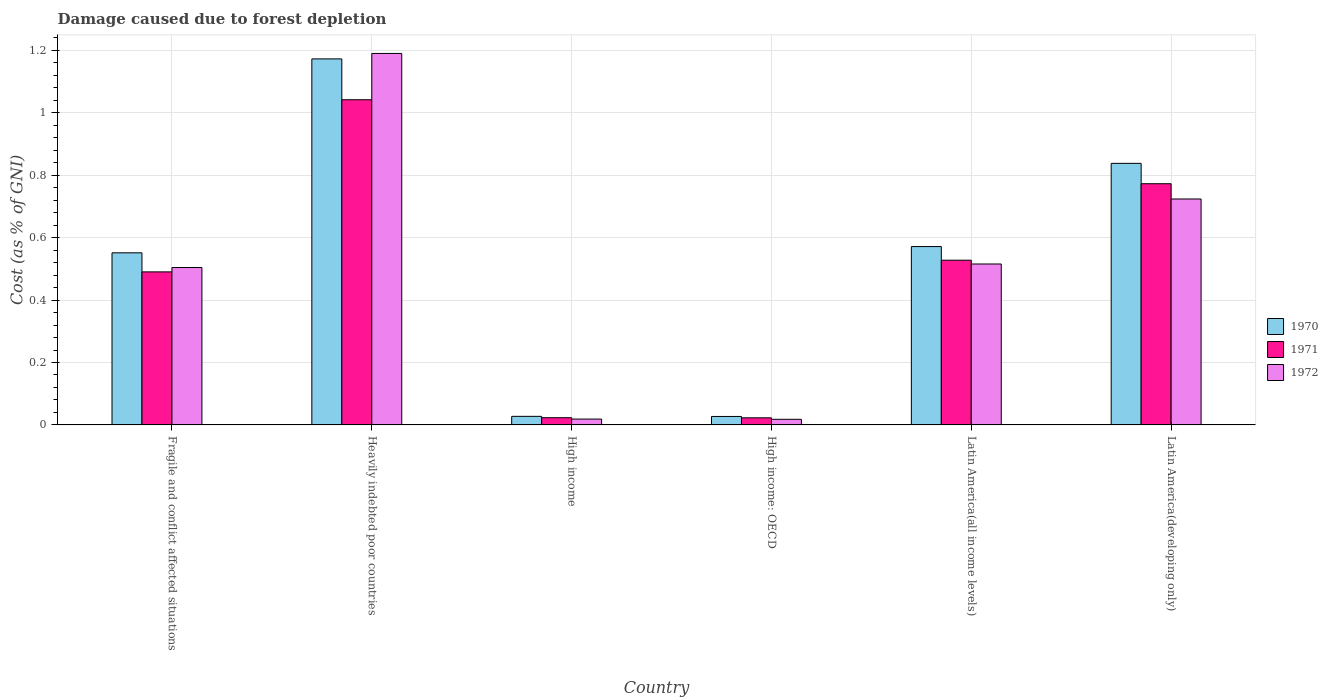What is the label of the 3rd group of bars from the left?
Offer a very short reply. High income. In how many cases, is the number of bars for a given country not equal to the number of legend labels?
Your response must be concise. 0. What is the cost of damage caused due to forest depletion in 1971 in Latin America(all income levels)?
Provide a succinct answer. 0.53. Across all countries, what is the maximum cost of damage caused due to forest depletion in 1972?
Give a very brief answer. 1.19. Across all countries, what is the minimum cost of damage caused due to forest depletion in 1970?
Your response must be concise. 0.03. In which country was the cost of damage caused due to forest depletion in 1970 maximum?
Provide a succinct answer. Heavily indebted poor countries. In which country was the cost of damage caused due to forest depletion in 1971 minimum?
Ensure brevity in your answer.  High income: OECD. What is the total cost of damage caused due to forest depletion in 1971 in the graph?
Provide a succinct answer. 2.88. What is the difference between the cost of damage caused due to forest depletion in 1970 in Fragile and conflict affected situations and that in Latin America(all income levels)?
Offer a very short reply. -0.02. What is the difference between the cost of damage caused due to forest depletion in 1971 in Latin America(developing only) and the cost of damage caused due to forest depletion in 1970 in High income: OECD?
Your answer should be compact. 0.75. What is the average cost of damage caused due to forest depletion in 1972 per country?
Your response must be concise. 0.5. What is the difference between the cost of damage caused due to forest depletion of/in 1970 and cost of damage caused due to forest depletion of/in 1971 in Latin America(developing only)?
Keep it short and to the point. 0.07. In how many countries, is the cost of damage caused due to forest depletion in 1972 greater than 0.7600000000000001 %?
Give a very brief answer. 1. What is the ratio of the cost of damage caused due to forest depletion in 1972 in Heavily indebted poor countries to that in Latin America(developing only)?
Offer a terse response. 1.64. Is the difference between the cost of damage caused due to forest depletion in 1970 in Heavily indebted poor countries and Latin America(developing only) greater than the difference between the cost of damage caused due to forest depletion in 1971 in Heavily indebted poor countries and Latin America(developing only)?
Your response must be concise. Yes. What is the difference between the highest and the second highest cost of damage caused due to forest depletion in 1971?
Your answer should be very brief. -0.27. What is the difference between the highest and the lowest cost of damage caused due to forest depletion in 1971?
Ensure brevity in your answer.  1.02. Is the sum of the cost of damage caused due to forest depletion in 1970 in Fragile and conflict affected situations and Latin America(all income levels) greater than the maximum cost of damage caused due to forest depletion in 1972 across all countries?
Your answer should be very brief. No. What does the 3rd bar from the left in High income represents?
Offer a very short reply. 1972. What does the 1st bar from the right in High income represents?
Provide a short and direct response. 1972. Is it the case that in every country, the sum of the cost of damage caused due to forest depletion in 1971 and cost of damage caused due to forest depletion in 1970 is greater than the cost of damage caused due to forest depletion in 1972?
Ensure brevity in your answer.  Yes. How many bars are there?
Your response must be concise. 18. Where does the legend appear in the graph?
Give a very brief answer. Center right. How many legend labels are there?
Your answer should be very brief. 3. How are the legend labels stacked?
Your response must be concise. Vertical. What is the title of the graph?
Ensure brevity in your answer.  Damage caused due to forest depletion. Does "1970" appear as one of the legend labels in the graph?
Make the answer very short. Yes. What is the label or title of the Y-axis?
Offer a very short reply. Cost (as % of GNI). What is the Cost (as % of GNI) of 1970 in Fragile and conflict affected situations?
Provide a succinct answer. 0.55. What is the Cost (as % of GNI) in 1971 in Fragile and conflict affected situations?
Offer a terse response. 0.49. What is the Cost (as % of GNI) of 1972 in Fragile and conflict affected situations?
Provide a short and direct response. 0.5. What is the Cost (as % of GNI) of 1970 in Heavily indebted poor countries?
Make the answer very short. 1.17. What is the Cost (as % of GNI) in 1971 in Heavily indebted poor countries?
Your answer should be very brief. 1.04. What is the Cost (as % of GNI) of 1972 in Heavily indebted poor countries?
Offer a very short reply. 1.19. What is the Cost (as % of GNI) of 1970 in High income?
Give a very brief answer. 0.03. What is the Cost (as % of GNI) in 1971 in High income?
Keep it short and to the point. 0.02. What is the Cost (as % of GNI) of 1972 in High income?
Offer a very short reply. 0.02. What is the Cost (as % of GNI) of 1970 in High income: OECD?
Offer a terse response. 0.03. What is the Cost (as % of GNI) of 1971 in High income: OECD?
Keep it short and to the point. 0.02. What is the Cost (as % of GNI) in 1972 in High income: OECD?
Your response must be concise. 0.02. What is the Cost (as % of GNI) in 1970 in Latin America(all income levels)?
Provide a succinct answer. 0.57. What is the Cost (as % of GNI) in 1971 in Latin America(all income levels)?
Offer a very short reply. 0.53. What is the Cost (as % of GNI) of 1972 in Latin America(all income levels)?
Make the answer very short. 0.52. What is the Cost (as % of GNI) in 1970 in Latin America(developing only)?
Offer a terse response. 0.84. What is the Cost (as % of GNI) of 1971 in Latin America(developing only)?
Offer a very short reply. 0.77. What is the Cost (as % of GNI) of 1972 in Latin America(developing only)?
Make the answer very short. 0.72. Across all countries, what is the maximum Cost (as % of GNI) in 1970?
Offer a very short reply. 1.17. Across all countries, what is the maximum Cost (as % of GNI) of 1971?
Your response must be concise. 1.04. Across all countries, what is the maximum Cost (as % of GNI) of 1972?
Your answer should be very brief. 1.19. Across all countries, what is the minimum Cost (as % of GNI) in 1970?
Give a very brief answer. 0.03. Across all countries, what is the minimum Cost (as % of GNI) in 1971?
Your response must be concise. 0.02. Across all countries, what is the minimum Cost (as % of GNI) of 1972?
Keep it short and to the point. 0.02. What is the total Cost (as % of GNI) of 1970 in the graph?
Make the answer very short. 3.19. What is the total Cost (as % of GNI) in 1971 in the graph?
Your response must be concise. 2.88. What is the total Cost (as % of GNI) in 1972 in the graph?
Your answer should be compact. 2.97. What is the difference between the Cost (as % of GNI) in 1970 in Fragile and conflict affected situations and that in Heavily indebted poor countries?
Keep it short and to the point. -0.62. What is the difference between the Cost (as % of GNI) in 1971 in Fragile and conflict affected situations and that in Heavily indebted poor countries?
Offer a very short reply. -0.55. What is the difference between the Cost (as % of GNI) of 1972 in Fragile and conflict affected situations and that in Heavily indebted poor countries?
Offer a very short reply. -0.69. What is the difference between the Cost (as % of GNI) of 1970 in Fragile and conflict affected situations and that in High income?
Offer a very short reply. 0.52. What is the difference between the Cost (as % of GNI) of 1971 in Fragile and conflict affected situations and that in High income?
Your answer should be compact. 0.47. What is the difference between the Cost (as % of GNI) of 1972 in Fragile and conflict affected situations and that in High income?
Offer a terse response. 0.49. What is the difference between the Cost (as % of GNI) in 1970 in Fragile and conflict affected situations and that in High income: OECD?
Your answer should be very brief. 0.52. What is the difference between the Cost (as % of GNI) of 1971 in Fragile and conflict affected situations and that in High income: OECD?
Your answer should be compact. 0.47. What is the difference between the Cost (as % of GNI) in 1972 in Fragile and conflict affected situations and that in High income: OECD?
Your answer should be compact. 0.49. What is the difference between the Cost (as % of GNI) of 1970 in Fragile and conflict affected situations and that in Latin America(all income levels)?
Your answer should be very brief. -0.02. What is the difference between the Cost (as % of GNI) of 1971 in Fragile and conflict affected situations and that in Latin America(all income levels)?
Offer a terse response. -0.04. What is the difference between the Cost (as % of GNI) in 1972 in Fragile and conflict affected situations and that in Latin America(all income levels)?
Your response must be concise. -0.01. What is the difference between the Cost (as % of GNI) of 1970 in Fragile and conflict affected situations and that in Latin America(developing only)?
Ensure brevity in your answer.  -0.29. What is the difference between the Cost (as % of GNI) in 1971 in Fragile and conflict affected situations and that in Latin America(developing only)?
Your answer should be compact. -0.28. What is the difference between the Cost (as % of GNI) of 1972 in Fragile and conflict affected situations and that in Latin America(developing only)?
Give a very brief answer. -0.22. What is the difference between the Cost (as % of GNI) of 1970 in Heavily indebted poor countries and that in High income?
Your response must be concise. 1.15. What is the difference between the Cost (as % of GNI) in 1971 in Heavily indebted poor countries and that in High income?
Provide a succinct answer. 1.02. What is the difference between the Cost (as % of GNI) in 1972 in Heavily indebted poor countries and that in High income?
Keep it short and to the point. 1.17. What is the difference between the Cost (as % of GNI) of 1970 in Heavily indebted poor countries and that in High income: OECD?
Ensure brevity in your answer.  1.15. What is the difference between the Cost (as % of GNI) of 1971 in Heavily indebted poor countries and that in High income: OECD?
Your answer should be compact. 1.02. What is the difference between the Cost (as % of GNI) of 1972 in Heavily indebted poor countries and that in High income: OECD?
Your answer should be very brief. 1.17. What is the difference between the Cost (as % of GNI) in 1970 in Heavily indebted poor countries and that in Latin America(all income levels)?
Make the answer very short. 0.6. What is the difference between the Cost (as % of GNI) of 1971 in Heavily indebted poor countries and that in Latin America(all income levels)?
Ensure brevity in your answer.  0.51. What is the difference between the Cost (as % of GNI) in 1972 in Heavily indebted poor countries and that in Latin America(all income levels)?
Give a very brief answer. 0.67. What is the difference between the Cost (as % of GNI) of 1970 in Heavily indebted poor countries and that in Latin America(developing only)?
Provide a succinct answer. 0.33. What is the difference between the Cost (as % of GNI) of 1971 in Heavily indebted poor countries and that in Latin America(developing only)?
Offer a terse response. 0.27. What is the difference between the Cost (as % of GNI) in 1972 in Heavily indebted poor countries and that in Latin America(developing only)?
Offer a terse response. 0.47. What is the difference between the Cost (as % of GNI) in 1970 in High income and that in High income: OECD?
Offer a very short reply. 0. What is the difference between the Cost (as % of GNI) of 1971 in High income and that in High income: OECD?
Give a very brief answer. 0. What is the difference between the Cost (as % of GNI) in 1972 in High income and that in High income: OECD?
Offer a very short reply. 0. What is the difference between the Cost (as % of GNI) of 1970 in High income and that in Latin America(all income levels)?
Your response must be concise. -0.54. What is the difference between the Cost (as % of GNI) of 1971 in High income and that in Latin America(all income levels)?
Offer a very short reply. -0.5. What is the difference between the Cost (as % of GNI) of 1972 in High income and that in Latin America(all income levels)?
Offer a terse response. -0.5. What is the difference between the Cost (as % of GNI) of 1970 in High income and that in Latin America(developing only)?
Your answer should be very brief. -0.81. What is the difference between the Cost (as % of GNI) of 1971 in High income and that in Latin America(developing only)?
Offer a very short reply. -0.75. What is the difference between the Cost (as % of GNI) of 1972 in High income and that in Latin America(developing only)?
Offer a very short reply. -0.71. What is the difference between the Cost (as % of GNI) in 1970 in High income: OECD and that in Latin America(all income levels)?
Offer a very short reply. -0.54. What is the difference between the Cost (as % of GNI) of 1971 in High income: OECD and that in Latin America(all income levels)?
Your answer should be compact. -0.51. What is the difference between the Cost (as % of GNI) in 1972 in High income: OECD and that in Latin America(all income levels)?
Keep it short and to the point. -0.5. What is the difference between the Cost (as % of GNI) of 1970 in High income: OECD and that in Latin America(developing only)?
Ensure brevity in your answer.  -0.81. What is the difference between the Cost (as % of GNI) in 1971 in High income: OECD and that in Latin America(developing only)?
Your response must be concise. -0.75. What is the difference between the Cost (as % of GNI) in 1972 in High income: OECD and that in Latin America(developing only)?
Offer a terse response. -0.71. What is the difference between the Cost (as % of GNI) of 1970 in Latin America(all income levels) and that in Latin America(developing only)?
Provide a short and direct response. -0.27. What is the difference between the Cost (as % of GNI) in 1971 in Latin America(all income levels) and that in Latin America(developing only)?
Your answer should be very brief. -0.25. What is the difference between the Cost (as % of GNI) of 1972 in Latin America(all income levels) and that in Latin America(developing only)?
Ensure brevity in your answer.  -0.21. What is the difference between the Cost (as % of GNI) of 1970 in Fragile and conflict affected situations and the Cost (as % of GNI) of 1971 in Heavily indebted poor countries?
Make the answer very short. -0.49. What is the difference between the Cost (as % of GNI) of 1970 in Fragile and conflict affected situations and the Cost (as % of GNI) of 1972 in Heavily indebted poor countries?
Offer a very short reply. -0.64. What is the difference between the Cost (as % of GNI) in 1970 in Fragile and conflict affected situations and the Cost (as % of GNI) in 1971 in High income?
Give a very brief answer. 0.53. What is the difference between the Cost (as % of GNI) of 1970 in Fragile and conflict affected situations and the Cost (as % of GNI) of 1972 in High income?
Your response must be concise. 0.53. What is the difference between the Cost (as % of GNI) in 1971 in Fragile and conflict affected situations and the Cost (as % of GNI) in 1972 in High income?
Give a very brief answer. 0.47. What is the difference between the Cost (as % of GNI) in 1970 in Fragile and conflict affected situations and the Cost (as % of GNI) in 1971 in High income: OECD?
Make the answer very short. 0.53. What is the difference between the Cost (as % of GNI) in 1970 in Fragile and conflict affected situations and the Cost (as % of GNI) in 1972 in High income: OECD?
Keep it short and to the point. 0.53. What is the difference between the Cost (as % of GNI) of 1971 in Fragile and conflict affected situations and the Cost (as % of GNI) of 1972 in High income: OECD?
Make the answer very short. 0.47. What is the difference between the Cost (as % of GNI) in 1970 in Fragile and conflict affected situations and the Cost (as % of GNI) in 1971 in Latin America(all income levels)?
Your answer should be very brief. 0.02. What is the difference between the Cost (as % of GNI) in 1970 in Fragile and conflict affected situations and the Cost (as % of GNI) in 1972 in Latin America(all income levels)?
Ensure brevity in your answer.  0.04. What is the difference between the Cost (as % of GNI) in 1971 in Fragile and conflict affected situations and the Cost (as % of GNI) in 1972 in Latin America(all income levels)?
Your answer should be very brief. -0.03. What is the difference between the Cost (as % of GNI) in 1970 in Fragile and conflict affected situations and the Cost (as % of GNI) in 1971 in Latin America(developing only)?
Your answer should be very brief. -0.22. What is the difference between the Cost (as % of GNI) of 1970 in Fragile and conflict affected situations and the Cost (as % of GNI) of 1972 in Latin America(developing only)?
Ensure brevity in your answer.  -0.17. What is the difference between the Cost (as % of GNI) in 1971 in Fragile and conflict affected situations and the Cost (as % of GNI) in 1972 in Latin America(developing only)?
Ensure brevity in your answer.  -0.23. What is the difference between the Cost (as % of GNI) of 1970 in Heavily indebted poor countries and the Cost (as % of GNI) of 1971 in High income?
Ensure brevity in your answer.  1.15. What is the difference between the Cost (as % of GNI) in 1970 in Heavily indebted poor countries and the Cost (as % of GNI) in 1972 in High income?
Offer a terse response. 1.15. What is the difference between the Cost (as % of GNI) of 1971 in Heavily indebted poor countries and the Cost (as % of GNI) of 1972 in High income?
Make the answer very short. 1.02. What is the difference between the Cost (as % of GNI) in 1970 in Heavily indebted poor countries and the Cost (as % of GNI) in 1971 in High income: OECD?
Offer a terse response. 1.15. What is the difference between the Cost (as % of GNI) of 1970 in Heavily indebted poor countries and the Cost (as % of GNI) of 1972 in High income: OECD?
Provide a succinct answer. 1.15. What is the difference between the Cost (as % of GNI) of 1971 in Heavily indebted poor countries and the Cost (as % of GNI) of 1972 in High income: OECD?
Offer a very short reply. 1.02. What is the difference between the Cost (as % of GNI) of 1970 in Heavily indebted poor countries and the Cost (as % of GNI) of 1971 in Latin America(all income levels)?
Offer a very short reply. 0.65. What is the difference between the Cost (as % of GNI) of 1970 in Heavily indebted poor countries and the Cost (as % of GNI) of 1972 in Latin America(all income levels)?
Provide a succinct answer. 0.66. What is the difference between the Cost (as % of GNI) of 1971 in Heavily indebted poor countries and the Cost (as % of GNI) of 1972 in Latin America(all income levels)?
Provide a short and direct response. 0.53. What is the difference between the Cost (as % of GNI) of 1970 in Heavily indebted poor countries and the Cost (as % of GNI) of 1972 in Latin America(developing only)?
Give a very brief answer. 0.45. What is the difference between the Cost (as % of GNI) of 1971 in Heavily indebted poor countries and the Cost (as % of GNI) of 1972 in Latin America(developing only)?
Provide a succinct answer. 0.32. What is the difference between the Cost (as % of GNI) of 1970 in High income and the Cost (as % of GNI) of 1971 in High income: OECD?
Give a very brief answer. 0. What is the difference between the Cost (as % of GNI) in 1970 in High income and the Cost (as % of GNI) in 1972 in High income: OECD?
Make the answer very short. 0.01. What is the difference between the Cost (as % of GNI) of 1971 in High income and the Cost (as % of GNI) of 1972 in High income: OECD?
Your answer should be compact. 0.01. What is the difference between the Cost (as % of GNI) in 1970 in High income and the Cost (as % of GNI) in 1971 in Latin America(all income levels)?
Provide a succinct answer. -0.5. What is the difference between the Cost (as % of GNI) of 1970 in High income and the Cost (as % of GNI) of 1972 in Latin America(all income levels)?
Offer a terse response. -0.49. What is the difference between the Cost (as % of GNI) in 1971 in High income and the Cost (as % of GNI) in 1972 in Latin America(all income levels)?
Ensure brevity in your answer.  -0.49. What is the difference between the Cost (as % of GNI) in 1970 in High income and the Cost (as % of GNI) in 1971 in Latin America(developing only)?
Provide a succinct answer. -0.75. What is the difference between the Cost (as % of GNI) of 1970 in High income and the Cost (as % of GNI) of 1972 in Latin America(developing only)?
Your response must be concise. -0.7. What is the difference between the Cost (as % of GNI) of 1971 in High income and the Cost (as % of GNI) of 1972 in Latin America(developing only)?
Your answer should be compact. -0.7. What is the difference between the Cost (as % of GNI) in 1970 in High income: OECD and the Cost (as % of GNI) in 1971 in Latin America(all income levels)?
Provide a succinct answer. -0.5. What is the difference between the Cost (as % of GNI) in 1970 in High income: OECD and the Cost (as % of GNI) in 1972 in Latin America(all income levels)?
Offer a very short reply. -0.49. What is the difference between the Cost (as % of GNI) in 1971 in High income: OECD and the Cost (as % of GNI) in 1972 in Latin America(all income levels)?
Offer a terse response. -0.49. What is the difference between the Cost (as % of GNI) of 1970 in High income: OECD and the Cost (as % of GNI) of 1971 in Latin America(developing only)?
Your answer should be very brief. -0.75. What is the difference between the Cost (as % of GNI) of 1970 in High income: OECD and the Cost (as % of GNI) of 1972 in Latin America(developing only)?
Your response must be concise. -0.7. What is the difference between the Cost (as % of GNI) in 1971 in High income: OECD and the Cost (as % of GNI) in 1972 in Latin America(developing only)?
Give a very brief answer. -0.7. What is the difference between the Cost (as % of GNI) of 1970 in Latin America(all income levels) and the Cost (as % of GNI) of 1971 in Latin America(developing only)?
Your answer should be compact. -0.2. What is the difference between the Cost (as % of GNI) of 1970 in Latin America(all income levels) and the Cost (as % of GNI) of 1972 in Latin America(developing only)?
Keep it short and to the point. -0.15. What is the difference between the Cost (as % of GNI) of 1971 in Latin America(all income levels) and the Cost (as % of GNI) of 1972 in Latin America(developing only)?
Make the answer very short. -0.2. What is the average Cost (as % of GNI) of 1970 per country?
Make the answer very short. 0.53. What is the average Cost (as % of GNI) in 1971 per country?
Your answer should be compact. 0.48. What is the average Cost (as % of GNI) in 1972 per country?
Your answer should be very brief. 0.5. What is the difference between the Cost (as % of GNI) in 1970 and Cost (as % of GNI) in 1971 in Fragile and conflict affected situations?
Provide a short and direct response. 0.06. What is the difference between the Cost (as % of GNI) of 1970 and Cost (as % of GNI) of 1972 in Fragile and conflict affected situations?
Provide a short and direct response. 0.05. What is the difference between the Cost (as % of GNI) in 1971 and Cost (as % of GNI) in 1972 in Fragile and conflict affected situations?
Provide a succinct answer. -0.01. What is the difference between the Cost (as % of GNI) in 1970 and Cost (as % of GNI) in 1971 in Heavily indebted poor countries?
Your answer should be compact. 0.13. What is the difference between the Cost (as % of GNI) of 1970 and Cost (as % of GNI) of 1972 in Heavily indebted poor countries?
Provide a succinct answer. -0.02. What is the difference between the Cost (as % of GNI) in 1971 and Cost (as % of GNI) in 1972 in Heavily indebted poor countries?
Give a very brief answer. -0.15. What is the difference between the Cost (as % of GNI) in 1970 and Cost (as % of GNI) in 1971 in High income?
Ensure brevity in your answer.  0. What is the difference between the Cost (as % of GNI) of 1970 and Cost (as % of GNI) of 1972 in High income?
Provide a short and direct response. 0.01. What is the difference between the Cost (as % of GNI) of 1971 and Cost (as % of GNI) of 1972 in High income?
Your answer should be compact. 0. What is the difference between the Cost (as % of GNI) in 1970 and Cost (as % of GNI) in 1971 in High income: OECD?
Your answer should be very brief. 0. What is the difference between the Cost (as % of GNI) of 1970 and Cost (as % of GNI) of 1972 in High income: OECD?
Provide a short and direct response. 0.01. What is the difference between the Cost (as % of GNI) in 1971 and Cost (as % of GNI) in 1972 in High income: OECD?
Offer a very short reply. 0. What is the difference between the Cost (as % of GNI) in 1970 and Cost (as % of GNI) in 1971 in Latin America(all income levels)?
Give a very brief answer. 0.04. What is the difference between the Cost (as % of GNI) of 1970 and Cost (as % of GNI) of 1972 in Latin America(all income levels)?
Your answer should be very brief. 0.06. What is the difference between the Cost (as % of GNI) of 1971 and Cost (as % of GNI) of 1972 in Latin America(all income levels)?
Make the answer very short. 0.01. What is the difference between the Cost (as % of GNI) in 1970 and Cost (as % of GNI) in 1971 in Latin America(developing only)?
Your answer should be compact. 0.07. What is the difference between the Cost (as % of GNI) in 1970 and Cost (as % of GNI) in 1972 in Latin America(developing only)?
Your answer should be compact. 0.11. What is the difference between the Cost (as % of GNI) in 1971 and Cost (as % of GNI) in 1972 in Latin America(developing only)?
Your response must be concise. 0.05. What is the ratio of the Cost (as % of GNI) of 1970 in Fragile and conflict affected situations to that in Heavily indebted poor countries?
Give a very brief answer. 0.47. What is the ratio of the Cost (as % of GNI) in 1971 in Fragile and conflict affected situations to that in Heavily indebted poor countries?
Keep it short and to the point. 0.47. What is the ratio of the Cost (as % of GNI) in 1972 in Fragile and conflict affected situations to that in Heavily indebted poor countries?
Offer a terse response. 0.42. What is the ratio of the Cost (as % of GNI) in 1970 in Fragile and conflict affected situations to that in High income?
Provide a succinct answer. 20.11. What is the ratio of the Cost (as % of GNI) of 1971 in Fragile and conflict affected situations to that in High income?
Give a very brief answer. 21.22. What is the ratio of the Cost (as % of GNI) of 1972 in Fragile and conflict affected situations to that in High income?
Offer a terse response. 26.95. What is the ratio of the Cost (as % of GNI) in 1970 in Fragile and conflict affected situations to that in High income: OECD?
Your answer should be very brief. 20.35. What is the ratio of the Cost (as % of GNI) of 1971 in Fragile and conflict affected situations to that in High income: OECD?
Offer a very short reply. 21.58. What is the ratio of the Cost (as % of GNI) of 1972 in Fragile and conflict affected situations to that in High income: OECD?
Give a very brief answer. 28.05. What is the ratio of the Cost (as % of GNI) in 1970 in Fragile and conflict affected situations to that in Latin America(all income levels)?
Your response must be concise. 0.96. What is the ratio of the Cost (as % of GNI) of 1971 in Fragile and conflict affected situations to that in Latin America(all income levels)?
Provide a short and direct response. 0.93. What is the ratio of the Cost (as % of GNI) in 1972 in Fragile and conflict affected situations to that in Latin America(all income levels)?
Your answer should be very brief. 0.98. What is the ratio of the Cost (as % of GNI) in 1970 in Fragile and conflict affected situations to that in Latin America(developing only)?
Your answer should be compact. 0.66. What is the ratio of the Cost (as % of GNI) of 1971 in Fragile and conflict affected situations to that in Latin America(developing only)?
Your answer should be very brief. 0.63. What is the ratio of the Cost (as % of GNI) in 1972 in Fragile and conflict affected situations to that in Latin America(developing only)?
Offer a terse response. 0.7. What is the ratio of the Cost (as % of GNI) of 1970 in Heavily indebted poor countries to that in High income?
Offer a terse response. 42.78. What is the ratio of the Cost (as % of GNI) in 1971 in Heavily indebted poor countries to that in High income?
Give a very brief answer. 45.1. What is the ratio of the Cost (as % of GNI) of 1972 in Heavily indebted poor countries to that in High income?
Provide a short and direct response. 63.61. What is the ratio of the Cost (as % of GNI) in 1970 in Heavily indebted poor countries to that in High income: OECD?
Your answer should be very brief. 43.29. What is the ratio of the Cost (as % of GNI) in 1971 in Heavily indebted poor countries to that in High income: OECD?
Your answer should be compact. 45.86. What is the ratio of the Cost (as % of GNI) of 1972 in Heavily indebted poor countries to that in High income: OECD?
Make the answer very short. 66.22. What is the ratio of the Cost (as % of GNI) of 1970 in Heavily indebted poor countries to that in Latin America(all income levels)?
Keep it short and to the point. 2.05. What is the ratio of the Cost (as % of GNI) in 1971 in Heavily indebted poor countries to that in Latin America(all income levels)?
Keep it short and to the point. 1.97. What is the ratio of the Cost (as % of GNI) of 1972 in Heavily indebted poor countries to that in Latin America(all income levels)?
Your response must be concise. 2.31. What is the ratio of the Cost (as % of GNI) in 1970 in Heavily indebted poor countries to that in Latin America(developing only)?
Provide a short and direct response. 1.4. What is the ratio of the Cost (as % of GNI) of 1971 in Heavily indebted poor countries to that in Latin America(developing only)?
Keep it short and to the point. 1.35. What is the ratio of the Cost (as % of GNI) in 1972 in Heavily indebted poor countries to that in Latin America(developing only)?
Your response must be concise. 1.64. What is the ratio of the Cost (as % of GNI) of 1971 in High income to that in High income: OECD?
Provide a short and direct response. 1.02. What is the ratio of the Cost (as % of GNI) of 1972 in High income to that in High income: OECD?
Keep it short and to the point. 1.04. What is the ratio of the Cost (as % of GNI) of 1970 in High income to that in Latin America(all income levels)?
Your answer should be very brief. 0.05. What is the ratio of the Cost (as % of GNI) of 1971 in High income to that in Latin America(all income levels)?
Keep it short and to the point. 0.04. What is the ratio of the Cost (as % of GNI) in 1972 in High income to that in Latin America(all income levels)?
Keep it short and to the point. 0.04. What is the ratio of the Cost (as % of GNI) of 1970 in High income to that in Latin America(developing only)?
Your response must be concise. 0.03. What is the ratio of the Cost (as % of GNI) of 1971 in High income to that in Latin America(developing only)?
Ensure brevity in your answer.  0.03. What is the ratio of the Cost (as % of GNI) in 1972 in High income to that in Latin America(developing only)?
Your response must be concise. 0.03. What is the ratio of the Cost (as % of GNI) in 1970 in High income: OECD to that in Latin America(all income levels)?
Give a very brief answer. 0.05. What is the ratio of the Cost (as % of GNI) of 1971 in High income: OECD to that in Latin America(all income levels)?
Your answer should be very brief. 0.04. What is the ratio of the Cost (as % of GNI) of 1972 in High income: OECD to that in Latin America(all income levels)?
Your response must be concise. 0.03. What is the ratio of the Cost (as % of GNI) in 1970 in High income: OECD to that in Latin America(developing only)?
Ensure brevity in your answer.  0.03. What is the ratio of the Cost (as % of GNI) of 1971 in High income: OECD to that in Latin America(developing only)?
Give a very brief answer. 0.03. What is the ratio of the Cost (as % of GNI) of 1972 in High income: OECD to that in Latin America(developing only)?
Offer a terse response. 0.02. What is the ratio of the Cost (as % of GNI) of 1970 in Latin America(all income levels) to that in Latin America(developing only)?
Keep it short and to the point. 0.68. What is the ratio of the Cost (as % of GNI) in 1971 in Latin America(all income levels) to that in Latin America(developing only)?
Your answer should be compact. 0.68. What is the ratio of the Cost (as % of GNI) of 1972 in Latin America(all income levels) to that in Latin America(developing only)?
Your answer should be compact. 0.71. What is the difference between the highest and the second highest Cost (as % of GNI) in 1970?
Ensure brevity in your answer.  0.33. What is the difference between the highest and the second highest Cost (as % of GNI) of 1971?
Make the answer very short. 0.27. What is the difference between the highest and the second highest Cost (as % of GNI) of 1972?
Offer a terse response. 0.47. What is the difference between the highest and the lowest Cost (as % of GNI) in 1970?
Ensure brevity in your answer.  1.15. What is the difference between the highest and the lowest Cost (as % of GNI) of 1971?
Your response must be concise. 1.02. What is the difference between the highest and the lowest Cost (as % of GNI) in 1972?
Offer a terse response. 1.17. 